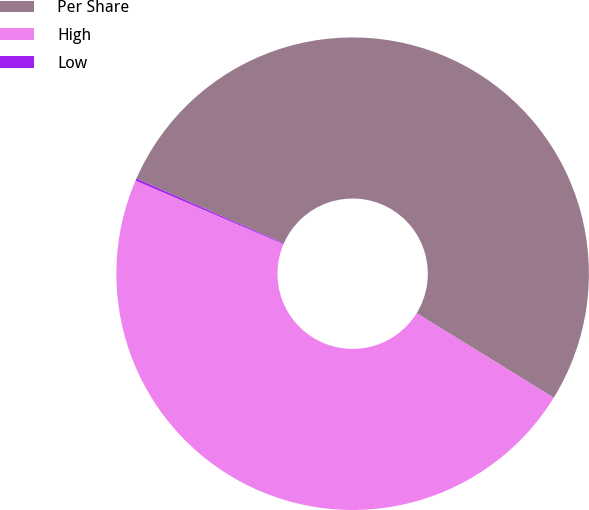<chart> <loc_0><loc_0><loc_500><loc_500><pie_chart><fcel>Per Share<fcel>High<fcel>Low<nl><fcel>52.2%<fcel>47.65%<fcel>0.15%<nl></chart> 